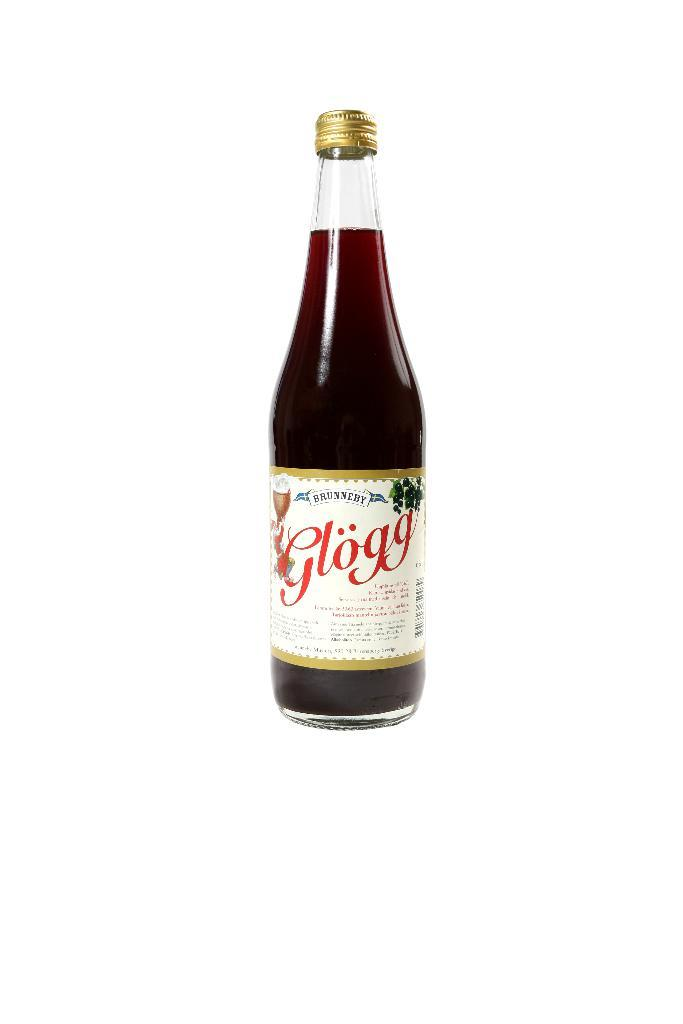<image>
Give a short and clear explanation of the subsequent image. A bottle with santa clause on it is called glogg. 